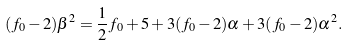Convert formula to latex. <formula><loc_0><loc_0><loc_500><loc_500>( f _ { 0 } - 2 ) \beta ^ { 2 } = \frac { 1 } { 2 } f _ { 0 } + 5 + 3 ( f _ { 0 } - 2 ) \alpha + 3 ( f _ { 0 } - 2 ) \alpha ^ { 2 } .</formula> 